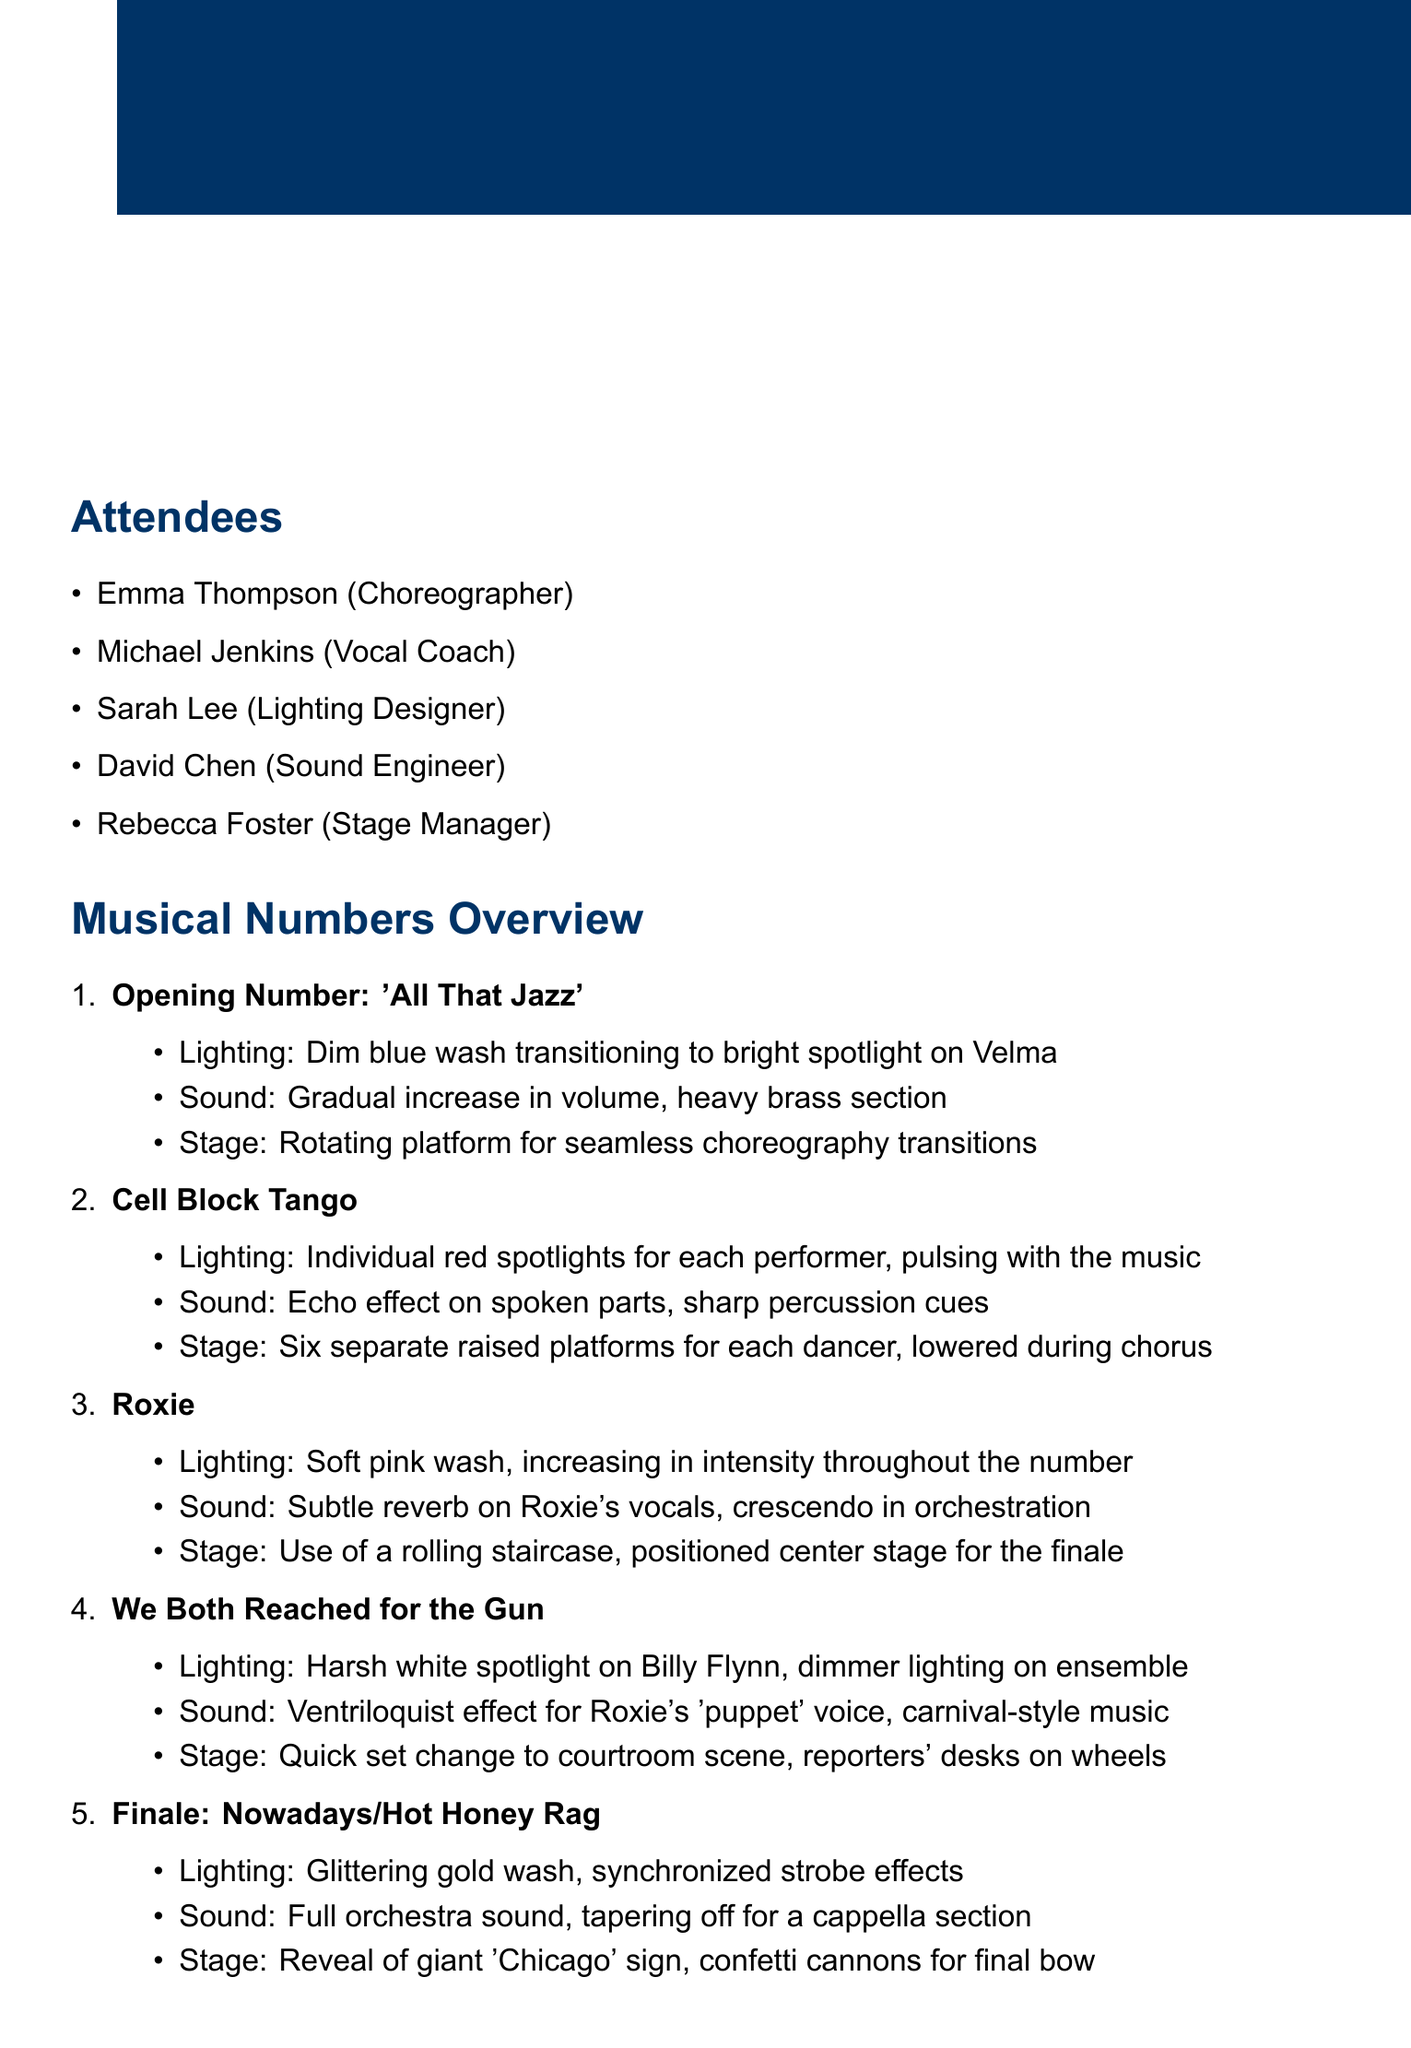What is the date of the meeting? The meeting was held on the date specified in the document.
Answer: 2023-05-15 Who is the lighting designer? The lighting designer's name is mentioned in the list of attendees.
Answer: Sarah Lee What is the first musical number listed? The first musical number in the document provides detail in the overview section.
Answer: All That Jazz How many performers have individual red spotlights in 'Cell Block Tango'? This information can be found in the details of the lighting cues for 'Cell Block Tango'.
Answer: Six What type of sound effect is used in 'We Both Reached for the Gun'? This detail is found in the sound section of the overview of that number.
Answer: Ventriloquist effect Which stage transition is mentioned for the finale? The detail about the stage transition for the finale can be found under the finale section in the document.
Answer: Reveal of giant 'Chicago' sign Who is responsible for refining choreography transitions? This task is mentioned in the action items section and identifies who is responsible and what the task is.
Answer: Emma What is Sarah required to adjust? This task is specifically noted in the action items regarding adjustments she needs to make.
Answer: Timing of lighting cues in 'Roxie' 